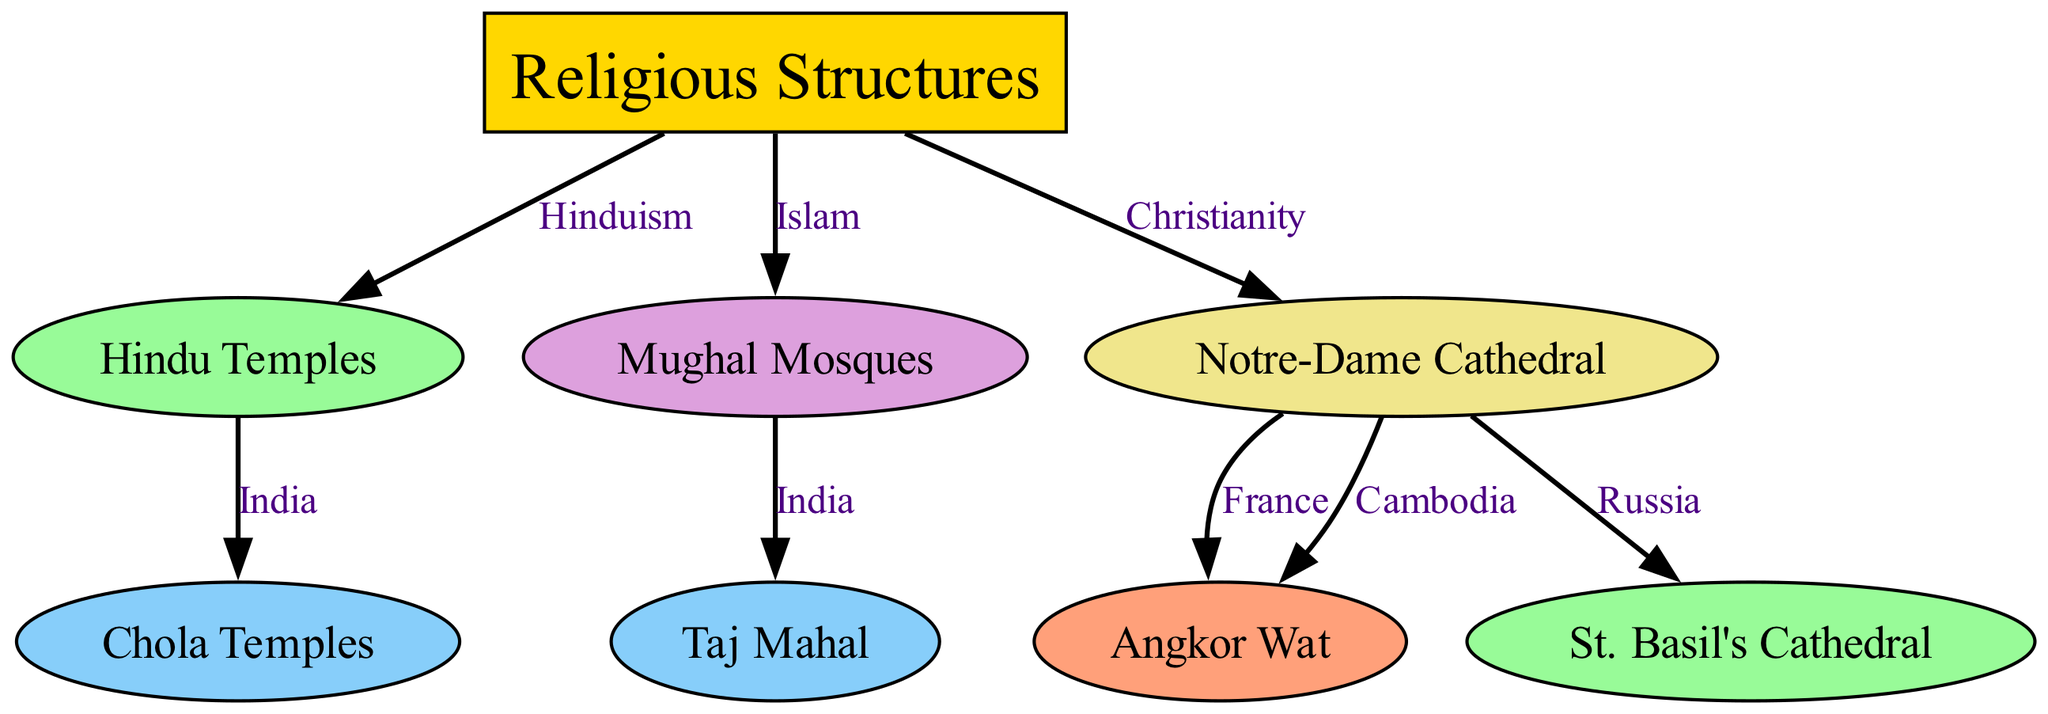What are the main categories of religious structures in the diagram? The diagram has a primary node labeled "Religious Structures," which is the foundational category that encompasses various types of religious architectures.
Answer: Religious Structures How many types of religious structures are shown in the diagram? The diagram displays eight nodes in total that represent various religious structures, including temples and cathedrals.
Answer: Eight Which religious structure is linked to Hinduism? The diagram shows an edge from "Religious Structures" to "Hindu Temples," indicating that Hindu Temples are categorized under Hinduism.
Answer: Hindu Temples What is the relationship between Mughal Mosques and the Taj Mahal? The diagram indicates that both "Mughal Mosques" and "Taj Mahal" are connected through the label "India," meaning they both represent Islamic architecture in India.
Answer: India Which structure is a representation of Christianity in the diagram? The edge from "Religious Structures" to "Notre-Dame Cathedral," labeled with Christianity, identifies this cathedral as a representation of Christianity.
Answer: Notre-Dame Cathedral Which country is associated with both Notre-Dame Cathedral and Angkor Wat based on the diagram? The diagram displays an edge from "Notre-Dame Cathedral" to "Angkor Wat," showing that they both have edges connected with countries that were important to their architecture, with France and Cambodia marked.
Answer: France and Cambodia Which two structures are connected to Christianity in the diagram? The diagram shows multiple edges connected to "Notre-Dame Cathedral," indicating its relationships with other structures. Specifically, "St. Basil's Cathedral" and "Angkor Wat" are connected through edges indicating different countries while under the Christianity category.
Answer: St. Basil's Cathedral and Angkor Wat What is unique about the Chola Temples in the diagram? "Chola Temples" are specifically connected to "Hindu Temples" through India, pointing to their regional and cultural significance within Hindu architecture.
Answer: India How does the diagram illustrate the architectural influences between different cultures? The diagram shows various connections between different religious structures and their respective cultural contexts, illustrating how architectural styles influence and derive from religious practices across cultures.
Answer: Architectural influences across cultures 